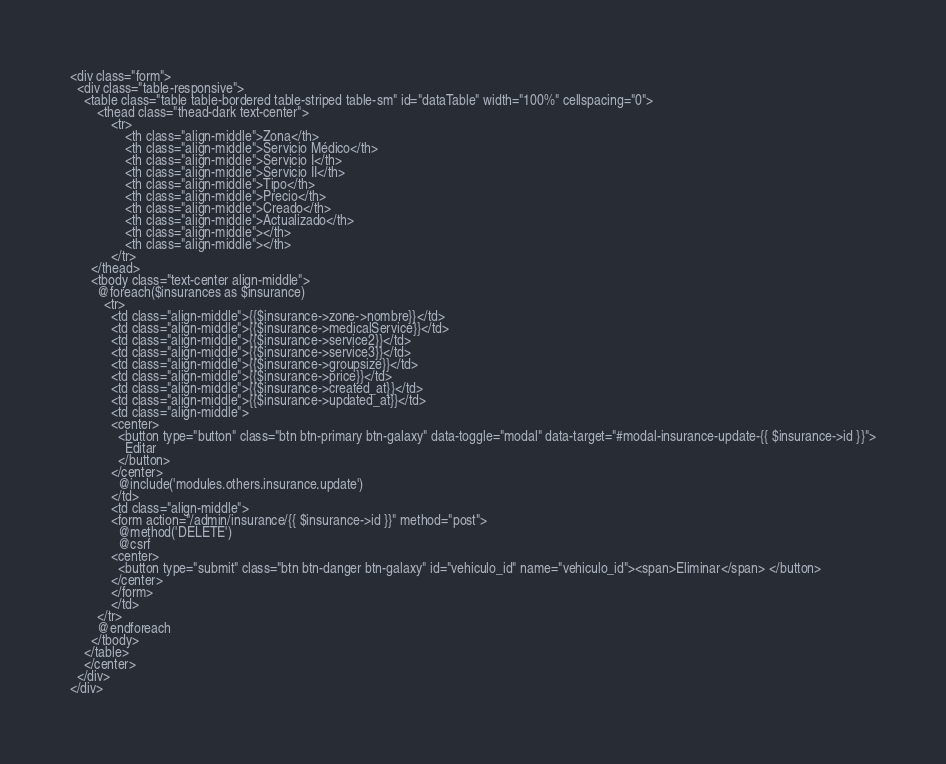Convert code to text. <code><loc_0><loc_0><loc_500><loc_500><_PHP_><div class="form">
  <div class="table-responsive">
    <table class="table table-bordered table-striped table-sm" id="dataTable" width="100%" cellspacing="0">
        <thead class="thead-dark text-center">
            <tr>
                <th class="align-middle">Zona</th>
                <th class="align-middle">Servicio Médico</th>
                <th class="align-middle">Servicio I</th>
                <th class="align-middle">Servicio II</th>
                <th class="align-middle">Tipo</th>
                <th class="align-middle">Precio</th>
                <th class="align-middle">Creado</th>
                <th class="align-middle">Actualizado</th>
                <th class="align-middle"></th>
                <th class="align-middle"></th>
            </tr>
      </thead>
      <tbody class="text-center align-middle">
        @foreach($insurances as $insurance)
          <tr>
            <td class="align-middle">{{$insurance->zone->nombre}}</td>
            <td class="align-middle">{{$insurance->medicalService}}</td>
            <td class="align-middle">{{$insurance->service2}}</td>
            <td class="align-middle">{{$insurance->service3}}</td>
            <td class="align-middle">{{$insurance->groupsize}}</td>
            <td class="align-middle">{{$insurance->price}}</td>
            <td class="align-middle">{{$insurance->created_at}}</td>
            <td class="align-middle">{{$insurance->updated_at}}</td>
            <td class="align-middle">
            <center>
              <button type="button" class="btn btn-primary btn-galaxy" data-toggle="modal" data-target="#modal-insurance-update-{{ $insurance->id }}">
                Editar
              </button>
            </center>
              @include('modules.others.insurance.update') 
            </td>
            <td class="align-middle">
            <form action="/admin/insurance/{{ $insurance->id }}" method="post">
              @method('DELETE')
              @csrf
            <center>
              <button type="submit" class="btn btn-danger btn-galaxy" id="vehiculo_id" name="vehiculo_id"><span>Eliminar</span> </button>
            </center>
            </form>
            </td>
        </tr>
        @endforeach
      </tbody>
    </table> 
    </center>
  </div>
</div>

</code> 